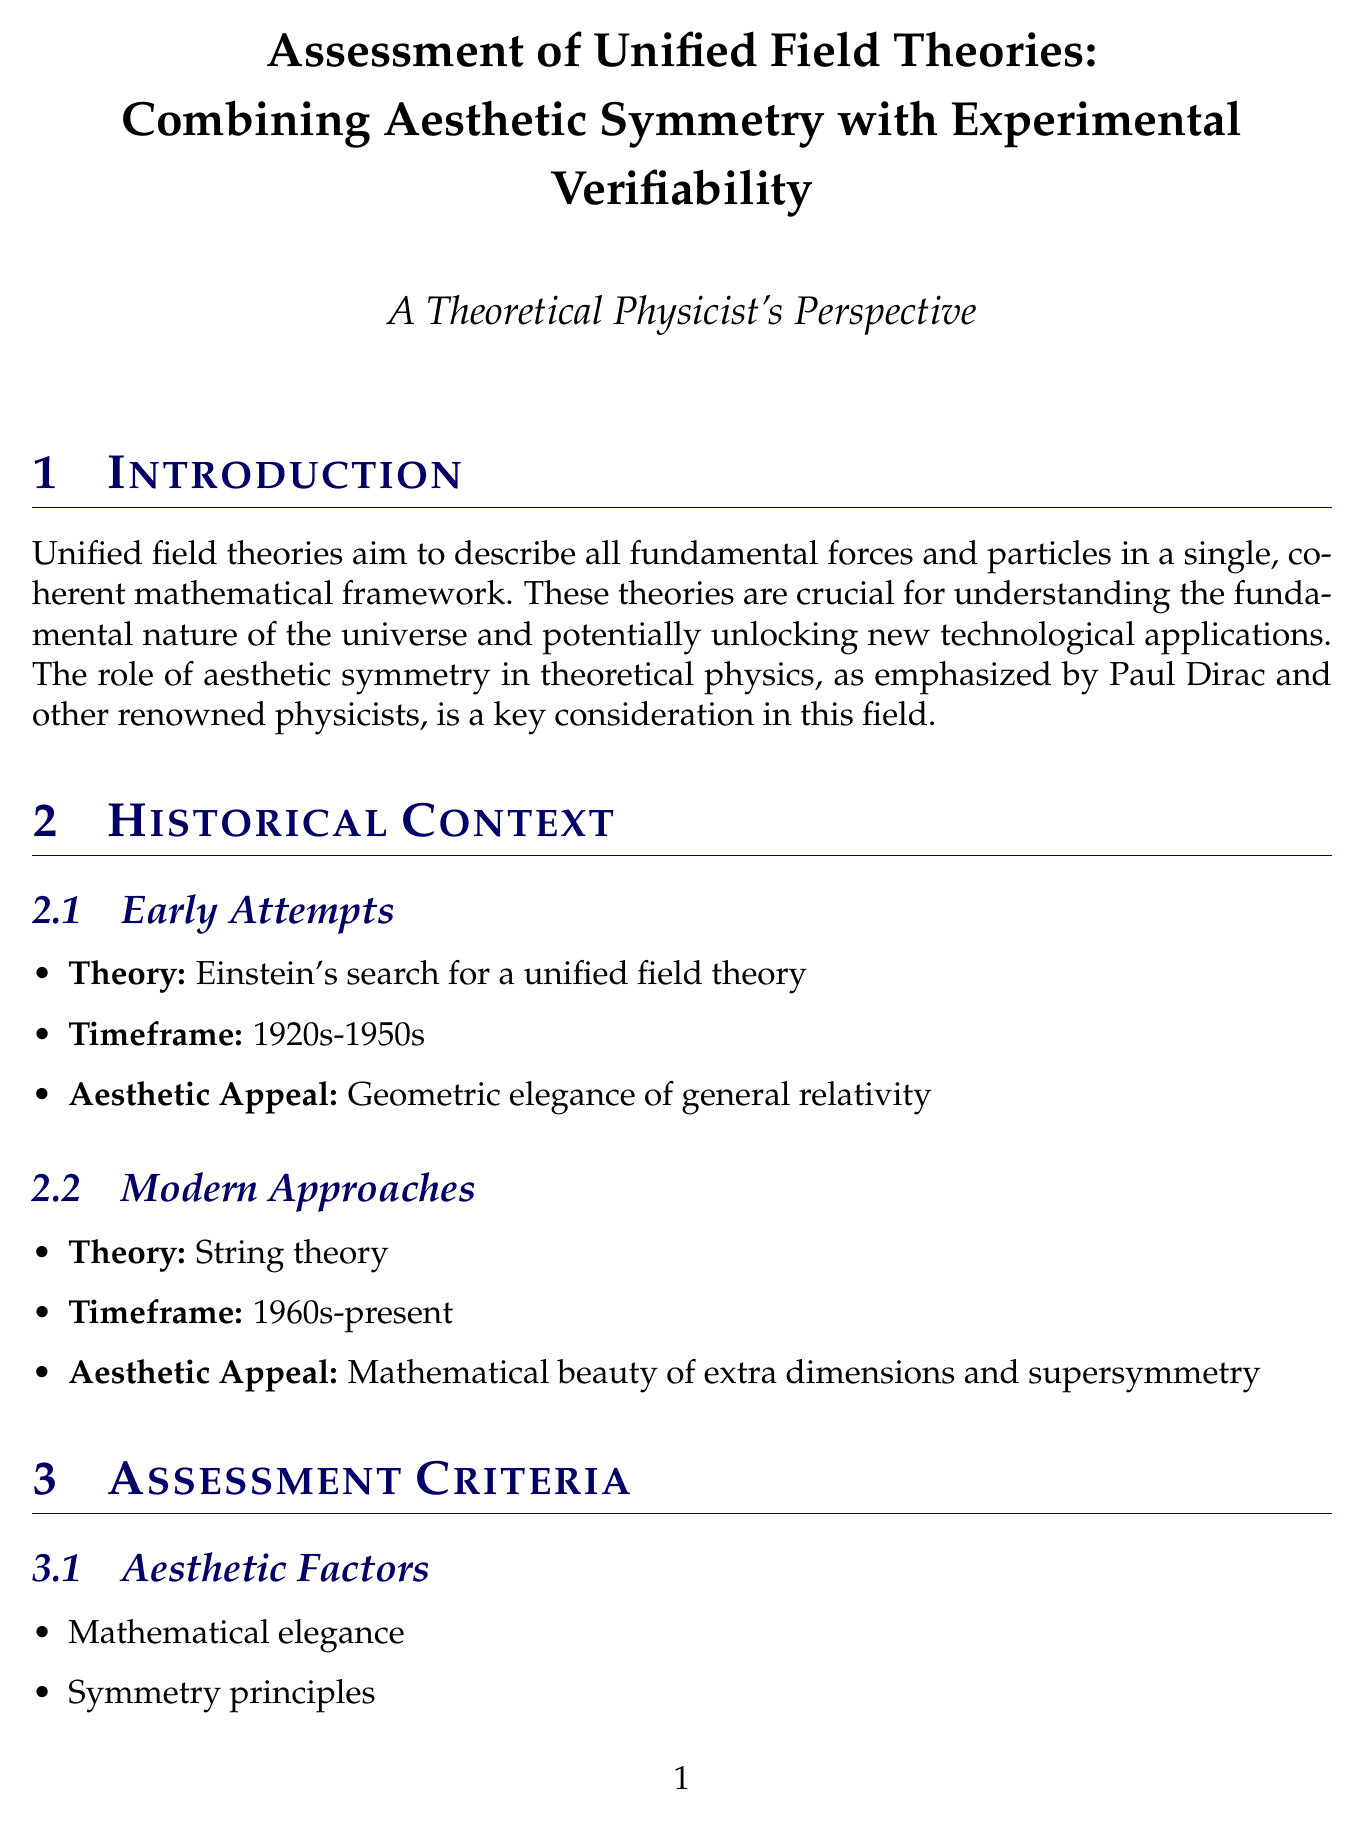What do unified field theories aim to describe? Unified field theories aim to describe all fundamental forces and particles in a single, coherent mathematical framework.
Answer: All fundamental forces and particles What time frame encompasses Einstein's search for a unified field theory? The timeframe for Einstein's search for a unified field theory is noted as the 1920s-1950s.
Answer: 1920s-1950s What is one of the aesthetic strengths of string theory? One aesthetic strength of string theory is its elegant mathematical structure.
Answer: Elegant mathematical structure What are the three criteria listed for experimental factors? The criteria listed for experimental factors include predictive power, falsifiability, and consistency with existing observations.
Answer: Predictive power, falsifiability, consistency with existing observations What is the philosophical perspective that views mathematical beauty as a guide to truth? The philosophical perspective that sees mathematical beauty as a guide to truth is known as Platonism.
Answer: Platonism What are two future theoretical advancements mentioned in the document? The document mentions holographic principles in quantum gravity and non-perturbative formulations of string theory as future theoretical advancements.
Answer: Holographic principles, non-perturbative formulations What is a practical approach suggested for balancing aesthetics and verifiability? A practical approach suggested is developing intermediate-scale theories with testable predictions.
Answer: Developing intermediate-scale theories What is emphasized as essential for pursuing a unified field theory? The essential aspects for pursuing a unified field theory include creative mathematical insight and a commitment to empirical validation.
Answer: Creative mathematical insight, empirical validation 